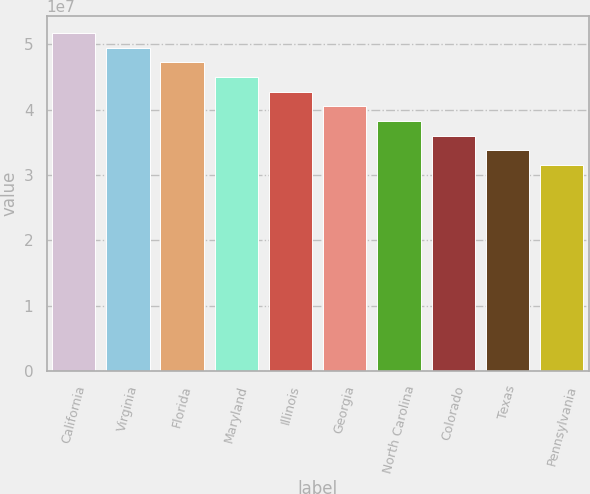<chart> <loc_0><loc_0><loc_500><loc_500><bar_chart><fcel>California<fcel>Virginia<fcel>Florida<fcel>Maryland<fcel>Illinois<fcel>Georgia<fcel>North Carolina<fcel>Colorado<fcel>Texas<fcel>Pennsylvania<nl><fcel>5.17752e+07<fcel>4.95259e+07<fcel>4.72765e+07<fcel>4.50271e+07<fcel>4.27777e+07<fcel>4.05284e+07<fcel>3.8279e+07<fcel>3.60296e+07<fcel>3.37802e+07<fcel>3.15309e+07<nl></chart> 